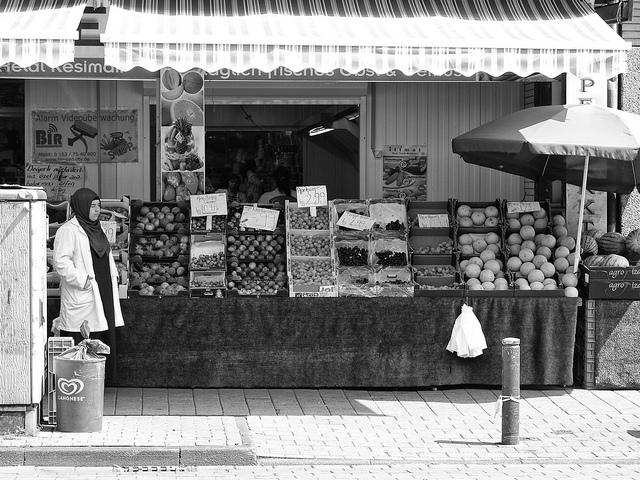The largest fruit shown here is what type of Fruit? Please explain your reasoning. melon. They are striped watermelons 